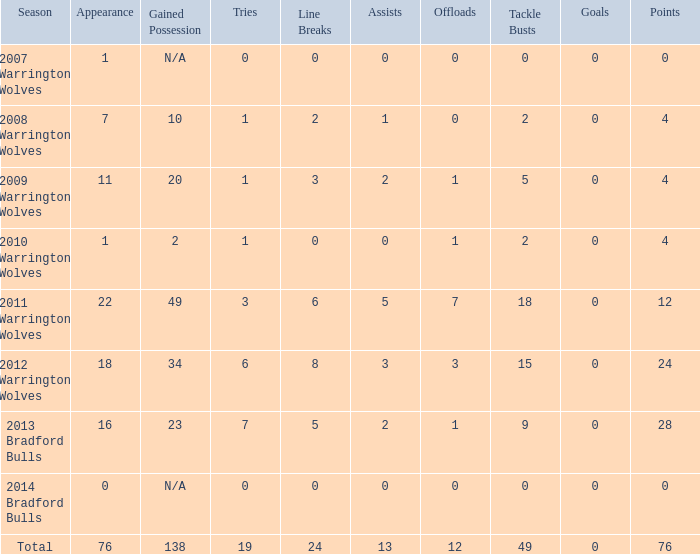How many times is tries 0 and appearance less than 0? 0.0. 